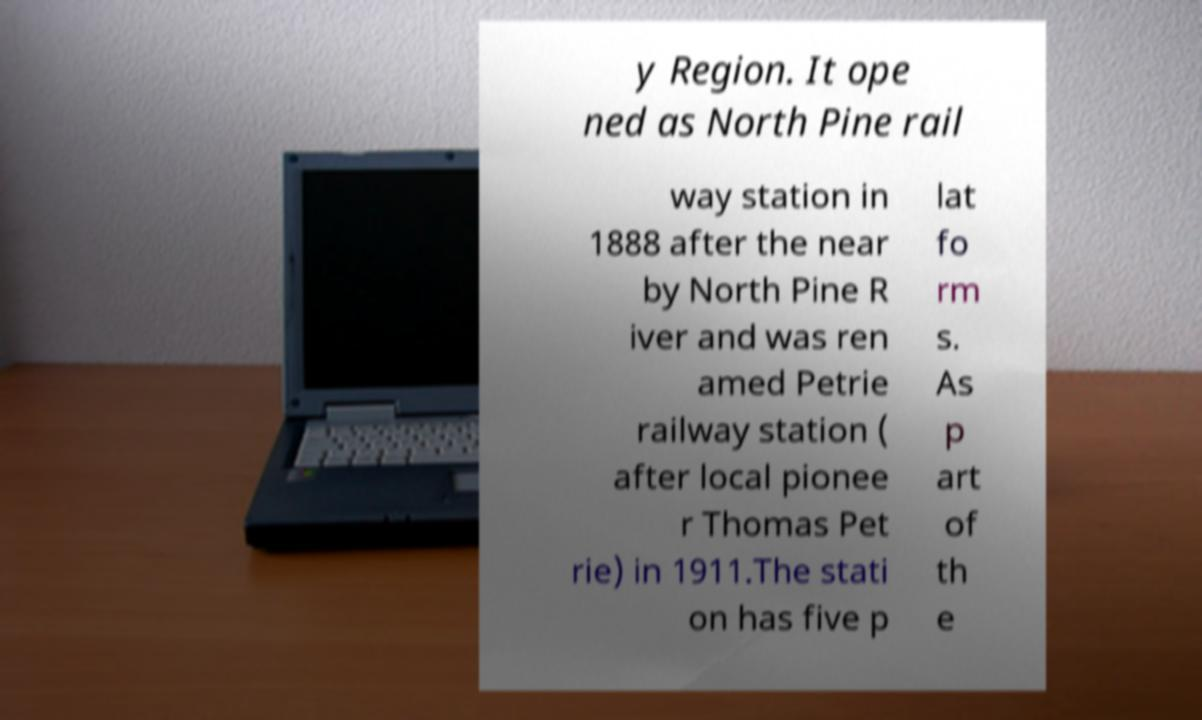Could you assist in decoding the text presented in this image and type it out clearly? y Region. It ope ned as North Pine rail way station in 1888 after the near by North Pine R iver and was ren amed Petrie railway station ( after local pionee r Thomas Pet rie) in 1911.The stati on has five p lat fo rm s. As p art of th e 